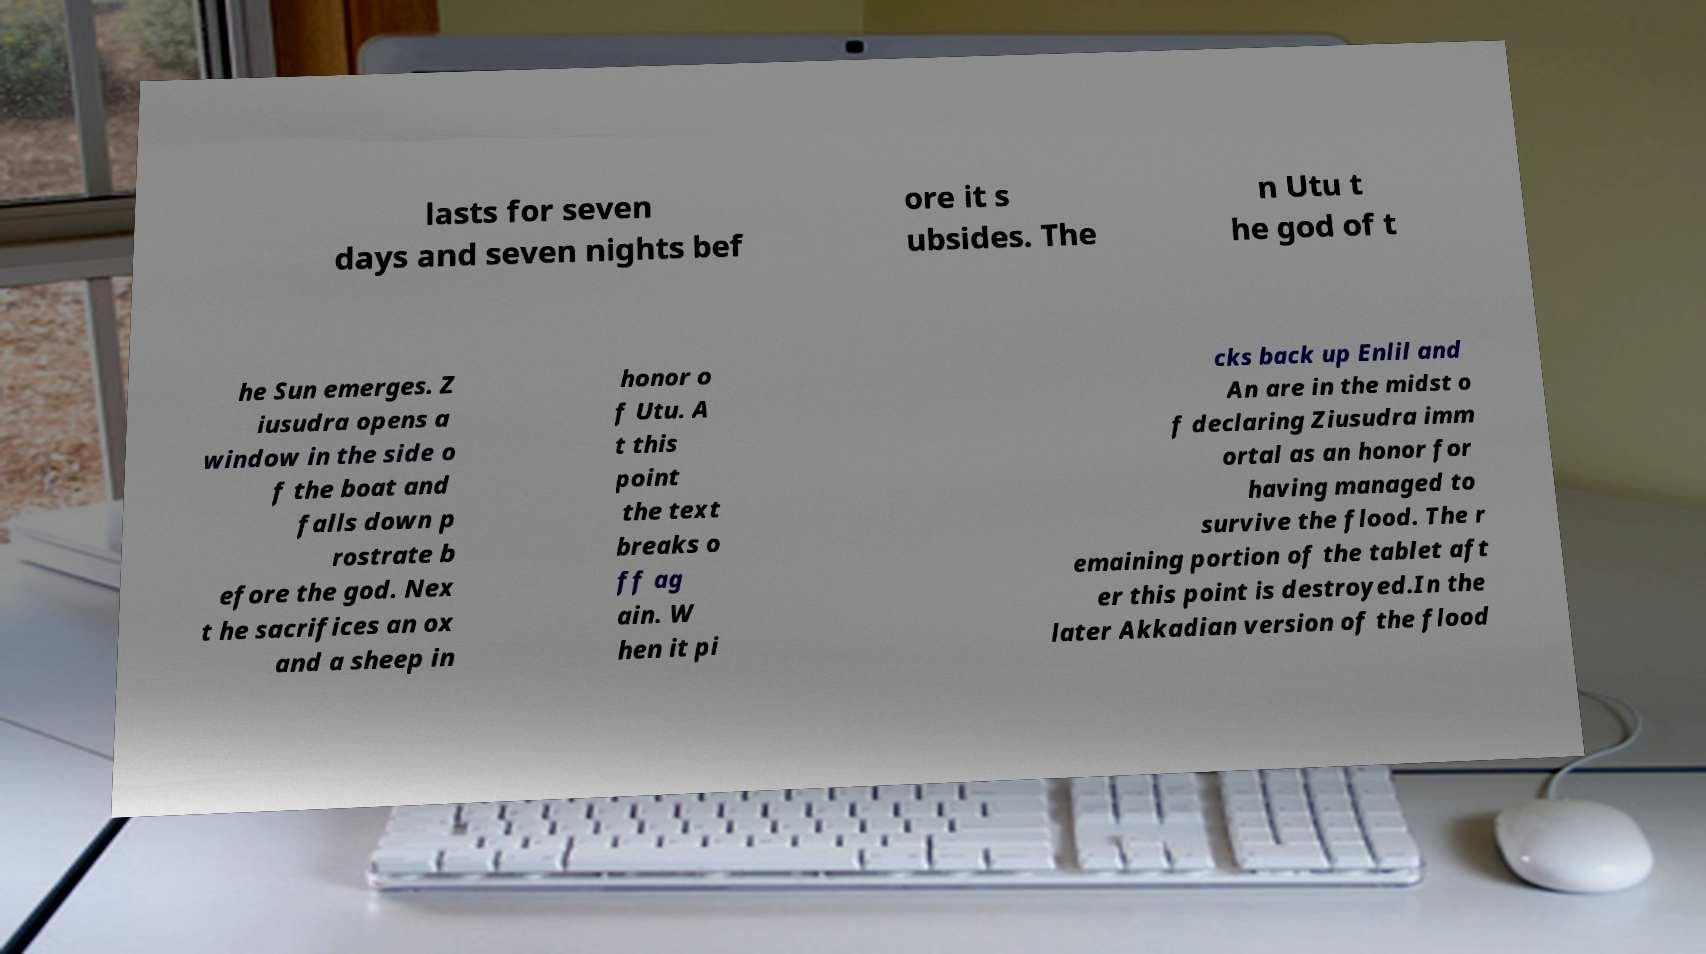Please identify and transcribe the text found in this image. lasts for seven days and seven nights bef ore it s ubsides. The n Utu t he god of t he Sun emerges. Z iusudra opens a window in the side o f the boat and falls down p rostrate b efore the god. Nex t he sacrifices an ox and a sheep in honor o f Utu. A t this point the text breaks o ff ag ain. W hen it pi cks back up Enlil and An are in the midst o f declaring Ziusudra imm ortal as an honor for having managed to survive the flood. The r emaining portion of the tablet aft er this point is destroyed.In the later Akkadian version of the flood 